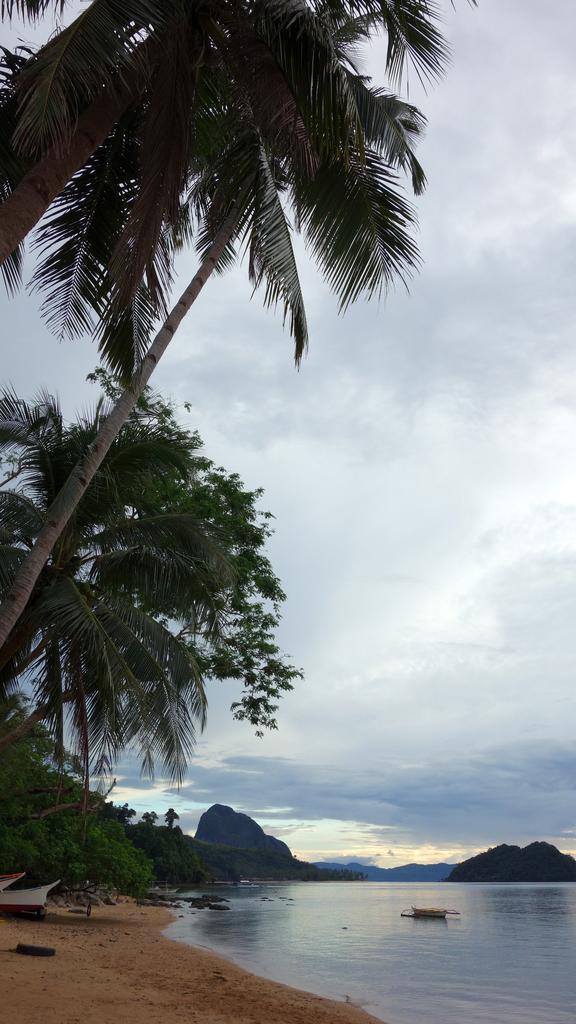Please provide a concise description of this image. In this image I can see water on the right side and on the left side of this image I can see few trees and few boats. In the background can see clouds and the sky. 